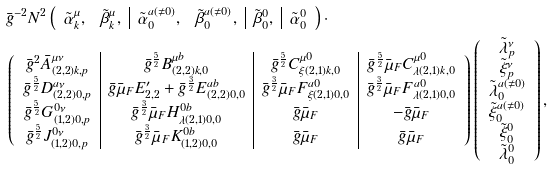Convert formula to latex. <formula><loc_0><loc_0><loc_500><loc_500>& \bar { g } ^ { - 2 } N ^ { 2 } \left ( \begin{array} { c c | c c | c | c } \tilde { \alpha } _ { k } ^ { \mu } , & \tilde { \beta } _ { k } ^ { \mu } , & \tilde { \alpha } _ { 0 } ^ { a ( \ne 0 ) } , & \tilde { \beta } _ { 0 } ^ { a ( \ne 0 ) } , & \tilde { \beta } _ { 0 } ^ { 0 } , & \tilde { \alpha } _ { 0 } ^ { 0 } \end{array} \right ) \cdot \\ & \left ( \begin{array} { c | c | c | c } \bar { g } ^ { 2 } \bar { A } _ { ( 2 , 2 ) k , p } ^ { \mu \nu } & \bar { g } ^ { \frac { 5 } { 2 } } B _ { ( 2 , 2 ) k , 0 } ^ { \mu b } & \bar { g } ^ { \frac { 5 } { 2 } } C _ { \xi ( 2 , 1 ) k , 0 } ^ { \mu 0 } & \bar { g } ^ { \frac { 5 } { 2 } } \bar { \mu } _ { F } C _ { \lambda ( 2 , 1 ) k , 0 } ^ { \mu 0 } \\ \bar { g } ^ { \frac { 5 } { 2 } } D _ { ( 2 , 2 ) 0 , p } ^ { a \nu } & \bar { g } \bar { \mu } _ { F } E ^ { \prime } _ { 2 , 2 } + \bar { g } ^ { \frac { 3 } { 2 } } E _ { ( 2 , 2 ) 0 , 0 } ^ { a b } & \bar { g } ^ { \frac { 3 } { 2 } } \bar { \mu } _ { F } F _ { \xi ( 2 , 1 ) 0 , 0 } ^ { a 0 } & \bar { g } ^ { \frac { 3 } { 2 } } \bar { \mu } _ { F } F _ { \lambda ( 2 , 1 ) 0 , 0 } ^ { a 0 } \\ \bar { g } ^ { \frac { 5 } { 2 } } G _ { ( 1 , 2 ) 0 , p } ^ { 0 \nu } & \bar { g } ^ { \frac { 3 } { 2 } } \bar { \mu } _ { F } H _ { \lambda ( 2 , 1 ) 0 , 0 } ^ { 0 b } & \bar { g } \bar { \mu } _ { F } & - \bar { g } \bar { \mu } _ { F } \\ \bar { g } ^ { \frac { 5 } { 2 } } J _ { ( 1 , 2 ) 0 , p } ^ { 0 \nu } & \bar { g } ^ { \frac { 3 } { 2 } } \bar { \mu } _ { F } K _ { ( 1 , 2 ) 0 , 0 } ^ { 0 b } & \bar { g } \bar { \mu } _ { F } & \bar { g } \bar { \mu } _ { F } \end{array} \right ) \left ( \begin{array} { c } \tilde { \lambda } _ { p } ^ { \nu } \\ \tilde { \xi } _ { p } ^ { \nu } \\ \tilde { \lambda } _ { 0 } ^ { a ( \ne 0 ) } \\ \tilde { \xi } _ { 0 } ^ { a ( \ne 0 ) } \\ \tilde { \xi } _ { 0 } ^ { 0 } \\ \tilde { \lambda } _ { 0 } ^ { 0 } \end{array} \right ) ,</formula> 